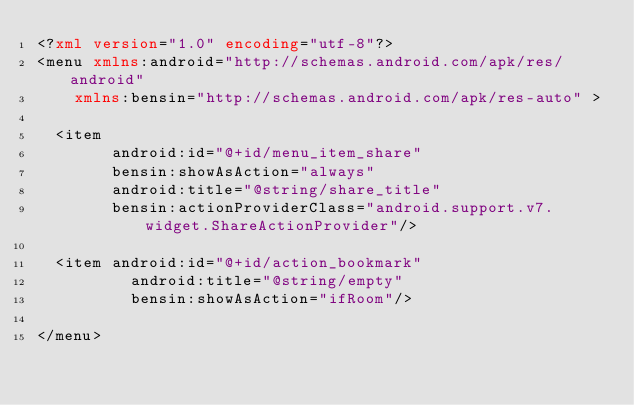Convert code to text. <code><loc_0><loc_0><loc_500><loc_500><_XML_><?xml version="1.0" encoding="utf-8"?>
<menu xmlns:android="http://schemas.android.com/apk/res/android" 
    xmlns:bensin="http://schemas.android.com/apk/res-auto" >
    
  <item 
        android:id="@+id/menu_item_share"
        bensin:showAsAction="always"
        android:title="@string/share_title"
        bensin:actionProviderClass="android.support.v7.widget.ShareActionProvider"/>
  
  <item android:id="@+id/action_bookmark"
          android:title="@string/empty"
          bensin:showAsAction="ifRoom"/>
    
</menu>
</code> 